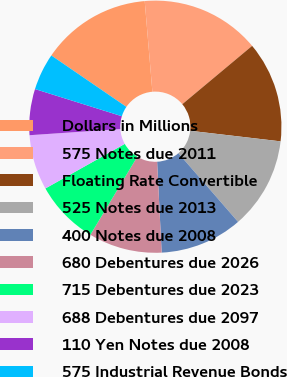<chart> <loc_0><loc_0><loc_500><loc_500><pie_chart><fcel>Dollars in Millions<fcel>575 Notes due 2011<fcel>Floating Rate Convertible<fcel>525 Notes due 2013<fcel>400 Notes due 2008<fcel>680 Debentures due 2026<fcel>715 Debentures due 2023<fcel>688 Debentures due 2097<fcel>110 Yen Notes due 2008<fcel>575 Industrial Revenue Bonds<nl><fcel>14.1%<fcel>15.27%<fcel>12.93%<fcel>11.76%<fcel>10.59%<fcel>9.41%<fcel>8.24%<fcel>7.07%<fcel>5.9%<fcel>4.73%<nl></chart> 